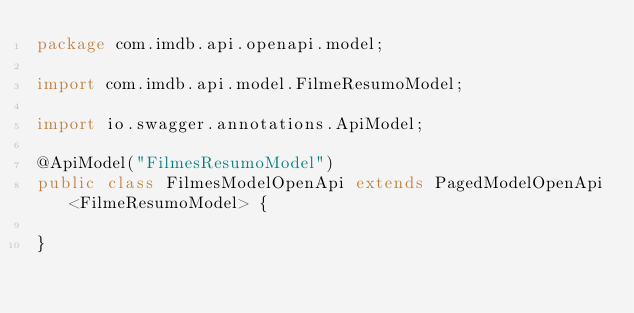Convert code to text. <code><loc_0><loc_0><loc_500><loc_500><_Java_>package com.imdb.api.openapi.model;

import com.imdb.api.model.FilmeResumoModel;

import io.swagger.annotations.ApiModel;

@ApiModel("FilmesResumoModel")
public class FilmesModelOpenApi extends PagedModelOpenApi<FilmeResumoModel> {
	
}</code> 